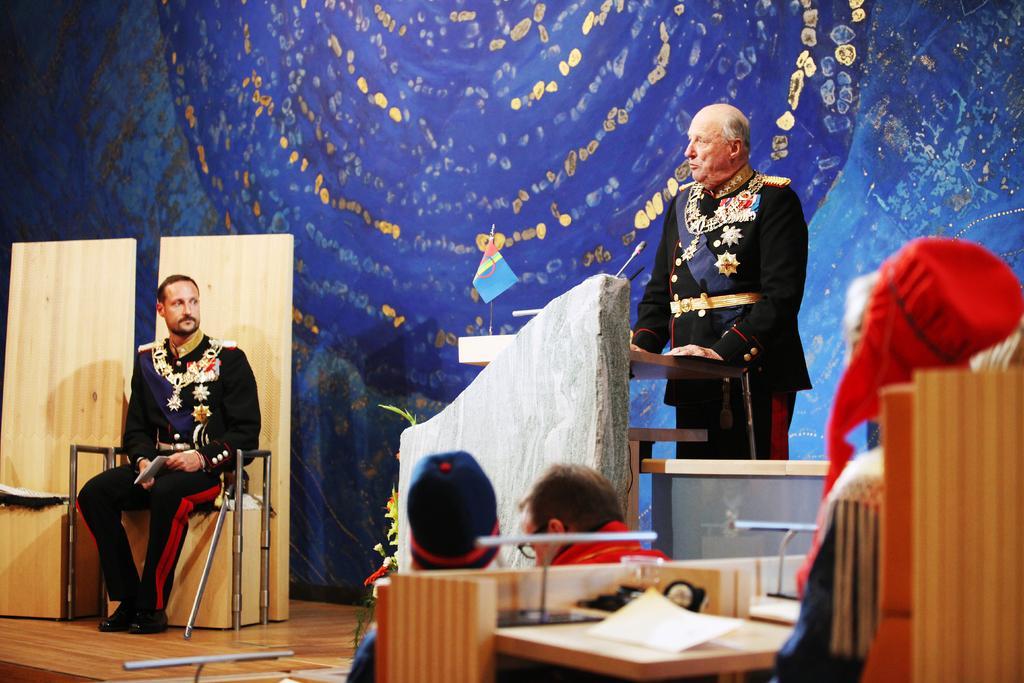How would you summarize this image in a sentence or two? In this image we can see a few people, among them one person is standing in front of the podium, on the podium, we can see a mic and a flag, there is a table on the table we can see papers and some other objects, in the background it looks a curtain. 